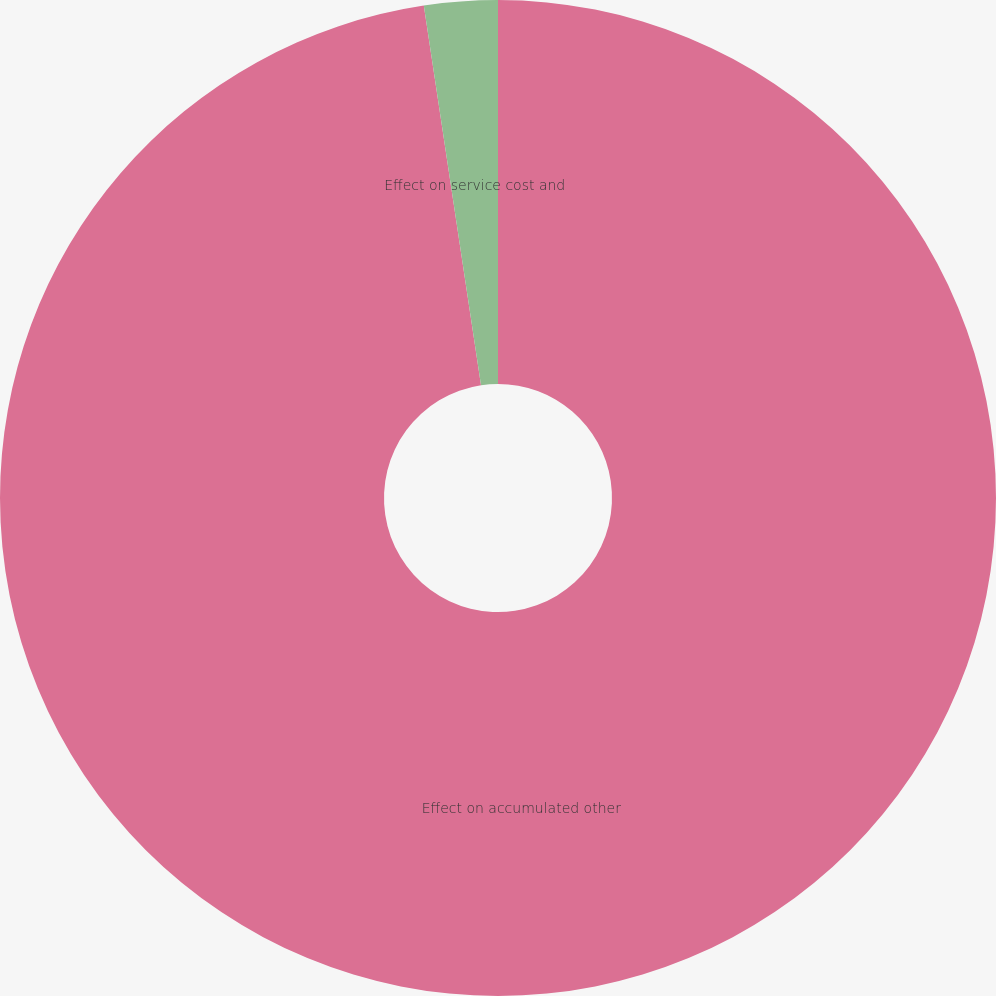<chart> <loc_0><loc_0><loc_500><loc_500><pie_chart><fcel>Effect on accumulated other<fcel>Effect on service cost and<nl><fcel>97.62%<fcel>2.38%<nl></chart> 